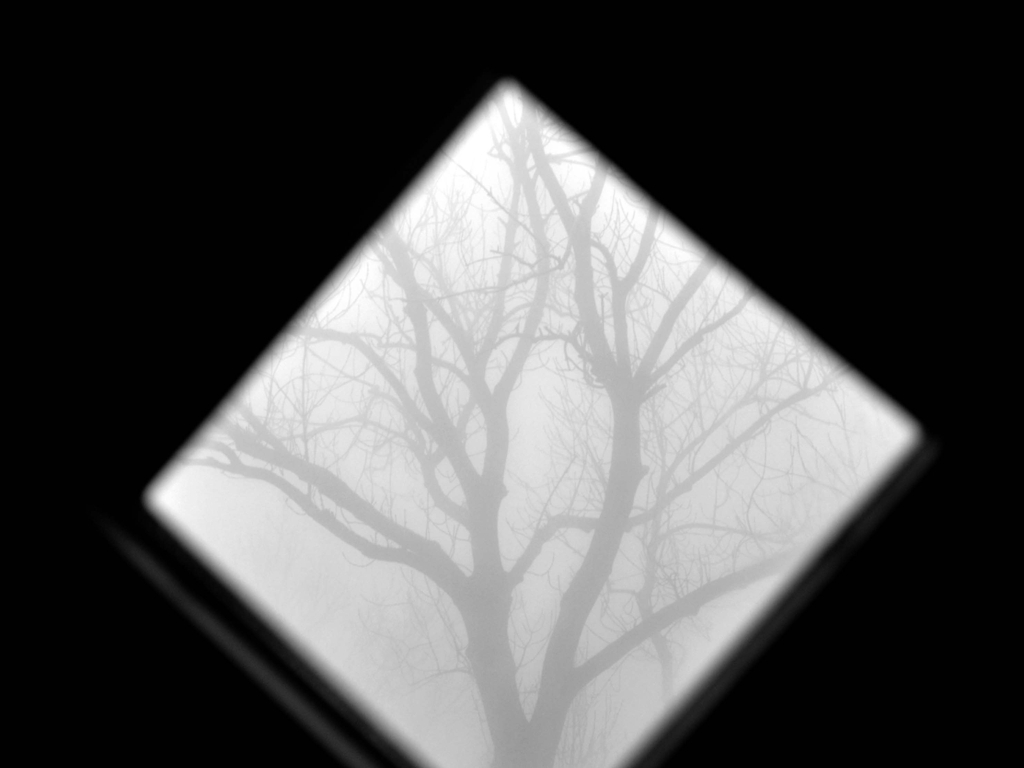If this image were to be used in a film or story, what genre do you think it would best suit and why? This image would fit seamlessly into a psychological thriller or mystery genre due to its eerie and foreboding atmosphere. The obscured vision and the lone, barren tree can be symbolic of hidden truths or secrets waiting to be uncovered, aligning well with themes of suspense and the unknown that are common in such narratives. 